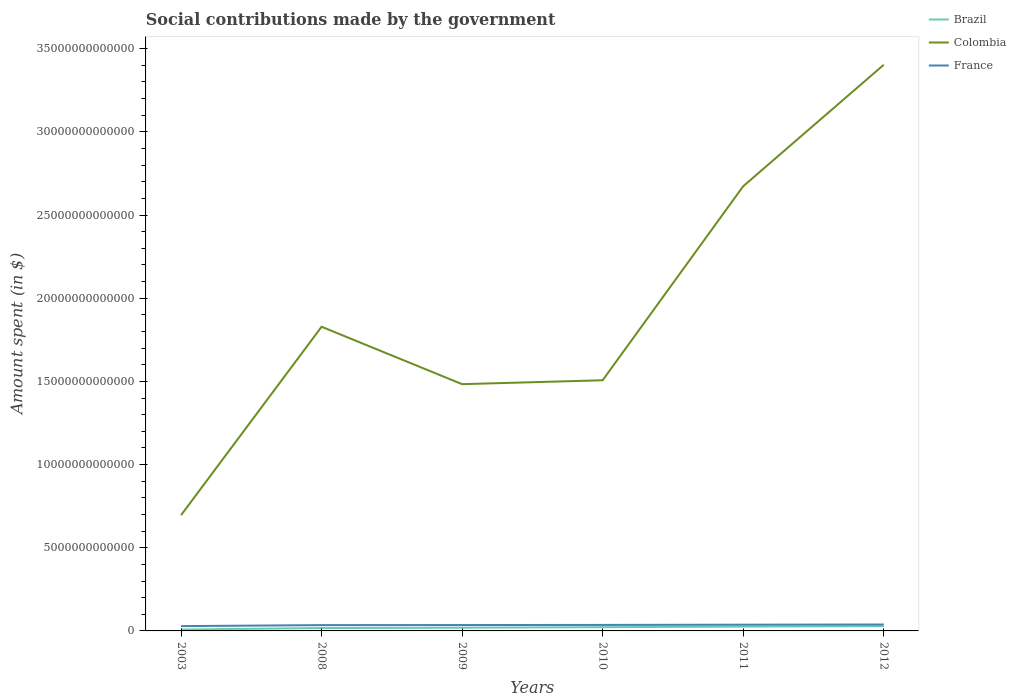Does the line corresponding to Colombia intersect with the line corresponding to France?
Your answer should be very brief. No. Is the number of lines equal to the number of legend labels?
Keep it short and to the point. Yes. Across all years, what is the maximum amount spent on social contributions in Brazil?
Give a very brief answer. 8.35e+1. What is the total amount spent on social contributions in Colombia in the graph?
Offer a terse response. -1.90e+13. What is the difference between the highest and the second highest amount spent on social contributions in France?
Ensure brevity in your answer.  9.66e+1. What is the difference between the highest and the lowest amount spent on social contributions in France?
Offer a very short reply. 4. How many lines are there?
Make the answer very short. 3. What is the difference between two consecutive major ticks on the Y-axis?
Provide a short and direct response. 5.00e+12. Are the values on the major ticks of Y-axis written in scientific E-notation?
Your response must be concise. No. Does the graph contain any zero values?
Give a very brief answer. No. Where does the legend appear in the graph?
Give a very brief answer. Top right. How are the legend labels stacked?
Give a very brief answer. Vertical. What is the title of the graph?
Ensure brevity in your answer.  Social contributions made by the government. Does "Argentina" appear as one of the legend labels in the graph?
Give a very brief answer. No. What is the label or title of the Y-axis?
Your response must be concise. Amount spent (in $). What is the Amount spent (in $) in Brazil in 2003?
Make the answer very short. 8.35e+1. What is the Amount spent (in $) of Colombia in 2003?
Give a very brief answer. 6.96e+12. What is the Amount spent (in $) of France in 2003?
Provide a short and direct response. 2.90e+11. What is the Amount spent (in $) of Brazil in 2008?
Provide a short and direct response. 1.73e+11. What is the Amount spent (in $) in Colombia in 2008?
Provide a short and direct response. 1.83e+13. What is the Amount spent (in $) in France in 2008?
Your answer should be very brief. 3.49e+11. What is the Amount spent (in $) of Brazil in 2009?
Your answer should be very brief. 1.93e+11. What is the Amount spent (in $) of Colombia in 2009?
Ensure brevity in your answer.  1.48e+13. What is the Amount spent (in $) in France in 2009?
Your answer should be compact. 3.53e+11. What is the Amount spent (in $) in Brazil in 2010?
Keep it short and to the point. 2.24e+11. What is the Amount spent (in $) of Colombia in 2010?
Provide a succinct answer. 1.51e+13. What is the Amount spent (in $) of France in 2010?
Keep it short and to the point. 3.60e+11. What is the Amount spent (in $) of Brazil in 2011?
Ensure brevity in your answer.  2.59e+11. What is the Amount spent (in $) in Colombia in 2011?
Offer a terse response. 2.67e+13. What is the Amount spent (in $) in France in 2011?
Keep it short and to the point. 3.75e+11. What is the Amount spent (in $) of Brazil in 2012?
Provide a short and direct response. 2.89e+11. What is the Amount spent (in $) in Colombia in 2012?
Your answer should be compact. 3.40e+13. What is the Amount spent (in $) in France in 2012?
Offer a terse response. 3.86e+11. Across all years, what is the maximum Amount spent (in $) in Brazil?
Your answer should be very brief. 2.89e+11. Across all years, what is the maximum Amount spent (in $) of Colombia?
Ensure brevity in your answer.  3.40e+13. Across all years, what is the maximum Amount spent (in $) of France?
Keep it short and to the point. 3.86e+11. Across all years, what is the minimum Amount spent (in $) of Brazil?
Provide a short and direct response. 8.35e+1. Across all years, what is the minimum Amount spent (in $) in Colombia?
Keep it short and to the point. 6.96e+12. Across all years, what is the minimum Amount spent (in $) of France?
Provide a succinct answer. 2.90e+11. What is the total Amount spent (in $) in Brazil in the graph?
Your answer should be compact. 1.22e+12. What is the total Amount spent (in $) in Colombia in the graph?
Your response must be concise. 1.16e+14. What is the total Amount spent (in $) of France in the graph?
Your answer should be compact. 2.11e+12. What is the difference between the Amount spent (in $) in Brazil in 2003 and that in 2008?
Make the answer very short. -8.96e+1. What is the difference between the Amount spent (in $) of Colombia in 2003 and that in 2008?
Your answer should be very brief. -1.13e+13. What is the difference between the Amount spent (in $) in France in 2003 and that in 2008?
Keep it short and to the point. -5.97e+1. What is the difference between the Amount spent (in $) of Brazil in 2003 and that in 2009?
Offer a very short reply. -1.09e+11. What is the difference between the Amount spent (in $) of Colombia in 2003 and that in 2009?
Offer a terse response. -7.88e+12. What is the difference between the Amount spent (in $) in France in 2003 and that in 2009?
Offer a very short reply. -6.34e+1. What is the difference between the Amount spent (in $) of Brazil in 2003 and that in 2010?
Provide a succinct answer. -1.41e+11. What is the difference between the Amount spent (in $) in Colombia in 2003 and that in 2010?
Make the answer very short. -8.11e+12. What is the difference between the Amount spent (in $) in France in 2003 and that in 2010?
Make the answer very short. -7.06e+1. What is the difference between the Amount spent (in $) of Brazil in 2003 and that in 2011?
Provide a succinct answer. -1.76e+11. What is the difference between the Amount spent (in $) of Colombia in 2003 and that in 2011?
Your answer should be compact. -1.98e+13. What is the difference between the Amount spent (in $) in France in 2003 and that in 2011?
Your answer should be very brief. -8.53e+1. What is the difference between the Amount spent (in $) of Brazil in 2003 and that in 2012?
Offer a very short reply. -2.06e+11. What is the difference between the Amount spent (in $) of Colombia in 2003 and that in 2012?
Ensure brevity in your answer.  -2.71e+13. What is the difference between the Amount spent (in $) in France in 2003 and that in 2012?
Your answer should be compact. -9.66e+1. What is the difference between the Amount spent (in $) of Brazil in 2008 and that in 2009?
Your answer should be very brief. -1.98e+1. What is the difference between the Amount spent (in $) of Colombia in 2008 and that in 2009?
Your answer should be compact. 3.45e+12. What is the difference between the Amount spent (in $) in France in 2008 and that in 2009?
Your answer should be compact. -3.68e+09. What is the difference between the Amount spent (in $) of Brazil in 2008 and that in 2010?
Keep it short and to the point. -5.12e+1. What is the difference between the Amount spent (in $) of Colombia in 2008 and that in 2010?
Provide a succinct answer. 3.22e+12. What is the difference between the Amount spent (in $) of France in 2008 and that in 2010?
Your response must be concise. -1.09e+1. What is the difference between the Amount spent (in $) in Brazil in 2008 and that in 2011?
Your response must be concise. -8.62e+1. What is the difference between the Amount spent (in $) in Colombia in 2008 and that in 2011?
Offer a very short reply. -8.45e+12. What is the difference between the Amount spent (in $) of France in 2008 and that in 2011?
Give a very brief answer. -2.55e+1. What is the difference between the Amount spent (in $) of Brazil in 2008 and that in 2012?
Offer a terse response. -1.16e+11. What is the difference between the Amount spent (in $) of Colombia in 2008 and that in 2012?
Your answer should be compact. -1.57e+13. What is the difference between the Amount spent (in $) of France in 2008 and that in 2012?
Your answer should be very brief. -3.69e+1. What is the difference between the Amount spent (in $) in Brazil in 2009 and that in 2010?
Keep it short and to the point. -3.14e+1. What is the difference between the Amount spent (in $) of Colombia in 2009 and that in 2010?
Offer a very short reply. -2.35e+11. What is the difference between the Amount spent (in $) of France in 2009 and that in 2010?
Provide a succinct answer. -7.20e+09. What is the difference between the Amount spent (in $) in Brazil in 2009 and that in 2011?
Make the answer very short. -6.64e+1. What is the difference between the Amount spent (in $) in Colombia in 2009 and that in 2011?
Provide a succinct answer. -1.19e+13. What is the difference between the Amount spent (in $) of France in 2009 and that in 2011?
Give a very brief answer. -2.19e+1. What is the difference between the Amount spent (in $) in Brazil in 2009 and that in 2012?
Provide a short and direct response. -9.66e+1. What is the difference between the Amount spent (in $) of Colombia in 2009 and that in 2012?
Provide a succinct answer. -1.92e+13. What is the difference between the Amount spent (in $) of France in 2009 and that in 2012?
Make the answer very short. -3.32e+1. What is the difference between the Amount spent (in $) in Brazil in 2010 and that in 2011?
Provide a succinct answer. -3.50e+1. What is the difference between the Amount spent (in $) of Colombia in 2010 and that in 2011?
Your answer should be very brief. -1.17e+13. What is the difference between the Amount spent (in $) in France in 2010 and that in 2011?
Make the answer very short. -1.47e+1. What is the difference between the Amount spent (in $) of Brazil in 2010 and that in 2012?
Provide a short and direct response. -6.52e+1. What is the difference between the Amount spent (in $) in Colombia in 2010 and that in 2012?
Give a very brief answer. -1.90e+13. What is the difference between the Amount spent (in $) of France in 2010 and that in 2012?
Your response must be concise. -2.60e+1. What is the difference between the Amount spent (in $) of Brazil in 2011 and that in 2012?
Offer a terse response. -3.02e+1. What is the difference between the Amount spent (in $) of Colombia in 2011 and that in 2012?
Offer a terse response. -7.30e+12. What is the difference between the Amount spent (in $) in France in 2011 and that in 2012?
Keep it short and to the point. -1.14e+1. What is the difference between the Amount spent (in $) of Brazil in 2003 and the Amount spent (in $) of Colombia in 2008?
Your answer should be very brief. -1.82e+13. What is the difference between the Amount spent (in $) of Brazil in 2003 and the Amount spent (in $) of France in 2008?
Provide a succinct answer. -2.66e+11. What is the difference between the Amount spent (in $) of Colombia in 2003 and the Amount spent (in $) of France in 2008?
Your answer should be very brief. 6.61e+12. What is the difference between the Amount spent (in $) in Brazil in 2003 and the Amount spent (in $) in Colombia in 2009?
Offer a very short reply. -1.48e+13. What is the difference between the Amount spent (in $) in Brazil in 2003 and the Amount spent (in $) in France in 2009?
Make the answer very short. -2.70e+11. What is the difference between the Amount spent (in $) in Colombia in 2003 and the Amount spent (in $) in France in 2009?
Offer a terse response. 6.60e+12. What is the difference between the Amount spent (in $) of Brazil in 2003 and the Amount spent (in $) of Colombia in 2010?
Make the answer very short. -1.50e+13. What is the difference between the Amount spent (in $) of Brazil in 2003 and the Amount spent (in $) of France in 2010?
Provide a short and direct response. -2.77e+11. What is the difference between the Amount spent (in $) of Colombia in 2003 and the Amount spent (in $) of France in 2010?
Your answer should be very brief. 6.60e+12. What is the difference between the Amount spent (in $) in Brazil in 2003 and the Amount spent (in $) in Colombia in 2011?
Keep it short and to the point. -2.66e+13. What is the difference between the Amount spent (in $) in Brazil in 2003 and the Amount spent (in $) in France in 2011?
Offer a very short reply. -2.91e+11. What is the difference between the Amount spent (in $) of Colombia in 2003 and the Amount spent (in $) of France in 2011?
Offer a terse response. 6.58e+12. What is the difference between the Amount spent (in $) of Brazil in 2003 and the Amount spent (in $) of Colombia in 2012?
Keep it short and to the point. -3.39e+13. What is the difference between the Amount spent (in $) of Brazil in 2003 and the Amount spent (in $) of France in 2012?
Offer a very short reply. -3.03e+11. What is the difference between the Amount spent (in $) in Colombia in 2003 and the Amount spent (in $) in France in 2012?
Provide a short and direct response. 6.57e+12. What is the difference between the Amount spent (in $) of Brazil in 2008 and the Amount spent (in $) of Colombia in 2009?
Your answer should be very brief. -1.47e+13. What is the difference between the Amount spent (in $) in Brazil in 2008 and the Amount spent (in $) in France in 2009?
Your response must be concise. -1.80e+11. What is the difference between the Amount spent (in $) of Colombia in 2008 and the Amount spent (in $) of France in 2009?
Offer a terse response. 1.79e+13. What is the difference between the Amount spent (in $) in Brazil in 2008 and the Amount spent (in $) in Colombia in 2010?
Keep it short and to the point. -1.49e+13. What is the difference between the Amount spent (in $) of Brazil in 2008 and the Amount spent (in $) of France in 2010?
Offer a terse response. -1.87e+11. What is the difference between the Amount spent (in $) of Colombia in 2008 and the Amount spent (in $) of France in 2010?
Offer a terse response. 1.79e+13. What is the difference between the Amount spent (in $) in Brazil in 2008 and the Amount spent (in $) in Colombia in 2011?
Ensure brevity in your answer.  -2.66e+13. What is the difference between the Amount spent (in $) of Brazil in 2008 and the Amount spent (in $) of France in 2011?
Provide a succinct answer. -2.02e+11. What is the difference between the Amount spent (in $) of Colombia in 2008 and the Amount spent (in $) of France in 2011?
Give a very brief answer. 1.79e+13. What is the difference between the Amount spent (in $) of Brazil in 2008 and the Amount spent (in $) of Colombia in 2012?
Make the answer very short. -3.39e+13. What is the difference between the Amount spent (in $) in Brazil in 2008 and the Amount spent (in $) in France in 2012?
Provide a short and direct response. -2.13e+11. What is the difference between the Amount spent (in $) of Colombia in 2008 and the Amount spent (in $) of France in 2012?
Ensure brevity in your answer.  1.79e+13. What is the difference between the Amount spent (in $) of Brazil in 2009 and the Amount spent (in $) of Colombia in 2010?
Your response must be concise. -1.49e+13. What is the difference between the Amount spent (in $) in Brazil in 2009 and the Amount spent (in $) in France in 2010?
Offer a very short reply. -1.67e+11. What is the difference between the Amount spent (in $) of Colombia in 2009 and the Amount spent (in $) of France in 2010?
Your answer should be compact. 1.45e+13. What is the difference between the Amount spent (in $) of Brazil in 2009 and the Amount spent (in $) of Colombia in 2011?
Ensure brevity in your answer.  -2.65e+13. What is the difference between the Amount spent (in $) of Brazil in 2009 and the Amount spent (in $) of France in 2011?
Give a very brief answer. -1.82e+11. What is the difference between the Amount spent (in $) in Colombia in 2009 and the Amount spent (in $) in France in 2011?
Provide a short and direct response. 1.45e+13. What is the difference between the Amount spent (in $) in Brazil in 2009 and the Amount spent (in $) in Colombia in 2012?
Your response must be concise. -3.38e+13. What is the difference between the Amount spent (in $) of Brazil in 2009 and the Amount spent (in $) of France in 2012?
Provide a succinct answer. -1.93e+11. What is the difference between the Amount spent (in $) in Colombia in 2009 and the Amount spent (in $) in France in 2012?
Give a very brief answer. 1.44e+13. What is the difference between the Amount spent (in $) in Brazil in 2010 and the Amount spent (in $) in Colombia in 2011?
Keep it short and to the point. -2.65e+13. What is the difference between the Amount spent (in $) in Brazil in 2010 and the Amount spent (in $) in France in 2011?
Your response must be concise. -1.51e+11. What is the difference between the Amount spent (in $) of Colombia in 2010 and the Amount spent (in $) of France in 2011?
Make the answer very short. 1.47e+13. What is the difference between the Amount spent (in $) in Brazil in 2010 and the Amount spent (in $) in Colombia in 2012?
Provide a succinct answer. -3.38e+13. What is the difference between the Amount spent (in $) in Brazil in 2010 and the Amount spent (in $) in France in 2012?
Your answer should be very brief. -1.62e+11. What is the difference between the Amount spent (in $) of Colombia in 2010 and the Amount spent (in $) of France in 2012?
Provide a succinct answer. 1.47e+13. What is the difference between the Amount spent (in $) in Brazil in 2011 and the Amount spent (in $) in Colombia in 2012?
Provide a succinct answer. -3.38e+13. What is the difference between the Amount spent (in $) of Brazil in 2011 and the Amount spent (in $) of France in 2012?
Offer a terse response. -1.27e+11. What is the difference between the Amount spent (in $) of Colombia in 2011 and the Amount spent (in $) of France in 2012?
Provide a short and direct response. 2.63e+13. What is the average Amount spent (in $) of Brazil per year?
Provide a short and direct response. 2.04e+11. What is the average Amount spent (in $) of Colombia per year?
Ensure brevity in your answer.  1.93e+13. What is the average Amount spent (in $) of France per year?
Ensure brevity in your answer.  3.52e+11. In the year 2003, what is the difference between the Amount spent (in $) in Brazil and Amount spent (in $) in Colombia?
Offer a terse response. -6.87e+12. In the year 2003, what is the difference between the Amount spent (in $) in Brazil and Amount spent (in $) in France?
Your answer should be compact. -2.06e+11. In the year 2003, what is the difference between the Amount spent (in $) in Colombia and Amount spent (in $) in France?
Your answer should be very brief. 6.67e+12. In the year 2008, what is the difference between the Amount spent (in $) in Brazil and Amount spent (in $) in Colombia?
Make the answer very short. -1.81e+13. In the year 2008, what is the difference between the Amount spent (in $) in Brazil and Amount spent (in $) in France?
Give a very brief answer. -1.76e+11. In the year 2008, what is the difference between the Amount spent (in $) of Colombia and Amount spent (in $) of France?
Keep it short and to the point. 1.79e+13. In the year 2009, what is the difference between the Amount spent (in $) in Brazil and Amount spent (in $) in Colombia?
Offer a terse response. -1.46e+13. In the year 2009, what is the difference between the Amount spent (in $) in Brazil and Amount spent (in $) in France?
Offer a terse response. -1.60e+11. In the year 2009, what is the difference between the Amount spent (in $) of Colombia and Amount spent (in $) of France?
Your answer should be very brief. 1.45e+13. In the year 2010, what is the difference between the Amount spent (in $) of Brazil and Amount spent (in $) of Colombia?
Provide a short and direct response. -1.48e+13. In the year 2010, what is the difference between the Amount spent (in $) of Brazil and Amount spent (in $) of France?
Ensure brevity in your answer.  -1.36e+11. In the year 2010, what is the difference between the Amount spent (in $) in Colombia and Amount spent (in $) in France?
Your answer should be very brief. 1.47e+13. In the year 2011, what is the difference between the Amount spent (in $) of Brazil and Amount spent (in $) of Colombia?
Provide a succinct answer. -2.65e+13. In the year 2011, what is the difference between the Amount spent (in $) in Brazil and Amount spent (in $) in France?
Keep it short and to the point. -1.16e+11. In the year 2011, what is the difference between the Amount spent (in $) in Colombia and Amount spent (in $) in France?
Give a very brief answer. 2.64e+13. In the year 2012, what is the difference between the Amount spent (in $) of Brazil and Amount spent (in $) of Colombia?
Give a very brief answer. -3.37e+13. In the year 2012, what is the difference between the Amount spent (in $) in Brazil and Amount spent (in $) in France?
Make the answer very short. -9.68e+1. In the year 2012, what is the difference between the Amount spent (in $) in Colombia and Amount spent (in $) in France?
Your response must be concise. 3.36e+13. What is the ratio of the Amount spent (in $) of Brazil in 2003 to that in 2008?
Offer a very short reply. 0.48. What is the ratio of the Amount spent (in $) of Colombia in 2003 to that in 2008?
Your answer should be compact. 0.38. What is the ratio of the Amount spent (in $) of France in 2003 to that in 2008?
Provide a short and direct response. 0.83. What is the ratio of the Amount spent (in $) of Brazil in 2003 to that in 2009?
Offer a very short reply. 0.43. What is the ratio of the Amount spent (in $) in Colombia in 2003 to that in 2009?
Your response must be concise. 0.47. What is the ratio of the Amount spent (in $) of France in 2003 to that in 2009?
Give a very brief answer. 0.82. What is the ratio of the Amount spent (in $) of Brazil in 2003 to that in 2010?
Provide a succinct answer. 0.37. What is the ratio of the Amount spent (in $) of Colombia in 2003 to that in 2010?
Make the answer very short. 0.46. What is the ratio of the Amount spent (in $) of France in 2003 to that in 2010?
Offer a terse response. 0.8. What is the ratio of the Amount spent (in $) in Brazil in 2003 to that in 2011?
Your response must be concise. 0.32. What is the ratio of the Amount spent (in $) of Colombia in 2003 to that in 2011?
Your response must be concise. 0.26. What is the ratio of the Amount spent (in $) of France in 2003 to that in 2011?
Offer a terse response. 0.77. What is the ratio of the Amount spent (in $) of Brazil in 2003 to that in 2012?
Make the answer very short. 0.29. What is the ratio of the Amount spent (in $) in Colombia in 2003 to that in 2012?
Ensure brevity in your answer.  0.2. What is the ratio of the Amount spent (in $) in France in 2003 to that in 2012?
Make the answer very short. 0.75. What is the ratio of the Amount spent (in $) in Brazil in 2008 to that in 2009?
Offer a very short reply. 0.9. What is the ratio of the Amount spent (in $) in Colombia in 2008 to that in 2009?
Your answer should be very brief. 1.23. What is the ratio of the Amount spent (in $) in Brazil in 2008 to that in 2010?
Provide a short and direct response. 0.77. What is the ratio of the Amount spent (in $) of Colombia in 2008 to that in 2010?
Make the answer very short. 1.21. What is the ratio of the Amount spent (in $) in France in 2008 to that in 2010?
Keep it short and to the point. 0.97. What is the ratio of the Amount spent (in $) in Brazil in 2008 to that in 2011?
Make the answer very short. 0.67. What is the ratio of the Amount spent (in $) in Colombia in 2008 to that in 2011?
Offer a terse response. 0.68. What is the ratio of the Amount spent (in $) in France in 2008 to that in 2011?
Offer a very short reply. 0.93. What is the ratio of the Amount spent (in $) of Brazil in 2008 to that in 2012?
Provide a succinct answer. 0.6. What is the ratio of the Amount spent (in $) in Colombia in 2008 to that in 2012?
Provide a succinct answer. 0.54. What is the ratio of the Amount spent (in $) of France in 2008 to that in 2012?
Your answer should be compact. 0.9. What is the ratio of the Amount spent (in $) in Brazil in 2009 to that in 2010?
Your response must be concise. 0.86. What is the ratio of the Amount spent (in $) of Colombia in 2009 to that in 2010?
Give a very brief answer. 0.98. What is the ratio of the Amount spent (in $) in France in 2009 to that in 2010?
Ensure brevity in your answer.  0.98. What is the ratio of the Amount spent (in $) of Brazil in 2009 to that in 2011?
Your response must be concise. 0.74. What is the ratio of the Amount spent (in $) of Colombia in 2009 to that in 2011?
Ensure brevity in your answer.  0.55. What is the ratio of the Amount spent (in $) in France in 2009 to that in 2011?
Provide a short and direct response. 0.94. What is the ratio of the Amount spent (in $) of Brazil in 2009 to that in 2012?
Make the answer very short. 0.67. What is the ratio of the Amount spent (in $) in Colombia in 2009 to that in 2012?
Keep it short and to the point. 0.44. What is the ratio of the Amount spent (in $) of France in 2009 to that in 2012?
Your response must be concise. 0.91. What is the ratio of the Amount spent (in $) of Brazil in 2010 to that in 2011?
Offer a terse response. 0.86. What is the ratio of the Amount spent (in $) of Colombia in 2010 to that in 2011?
Provide a short and direct response. 0.56. What is the ratio of the Amount spent (in $) in France in 2010 to that in 2011?
Make the answer very short. 0.96. What is the ratio of the Amount spent (in $) in Brazil in 2010 to that in 2012?
Your response must be concise. 0.77. What is the ratio of the Amount spent (in $) in Colombia in 2010 to that in 2012?
Keep it short and to the point. 0.44. What is the ratio of the Amount spent (in $) of France in 2010 to that in 2012?
Offer a terse response. 0.93. What is the ratio of the Amount spent (in $) of Brazil in 2011 to that in 2012?
Your response must be concise. 0.9. What is the ratio of the Amount spent (in $) of Colombia in 2011 to that in 2012?
Provide a succinct answer. 0.79. What is the ratio of the Amount spent (in $) in France in 2011 to that in 2012?
Your answer should be compact. 0.97. What is the difference between the highest and the second highest Amount spent (in $) of Brazil?
Give a very brief answer. 3.02e+1. What is the difference between the highest and the second highest Amount spent (in $) in Colombia?
Keep it short and to the point. 7.30e+12. What is the difference between the highest and the second highest Amount spent (in $) in France?
Make the answer very short. 1.14e+1. What is the difference between the highest and the lowest Amount spent (in $) of Brazil?
Your answer should be very brief. 2.06e+11. What is the difference between the highest and the lowest Amount spent (in $) in Colombia?
Your answer should be compact. 2.71e+13. What is the difference between the highest and the lowest Amount spent (in $) of France?
Offer a very short reply. 9.66e+1. 